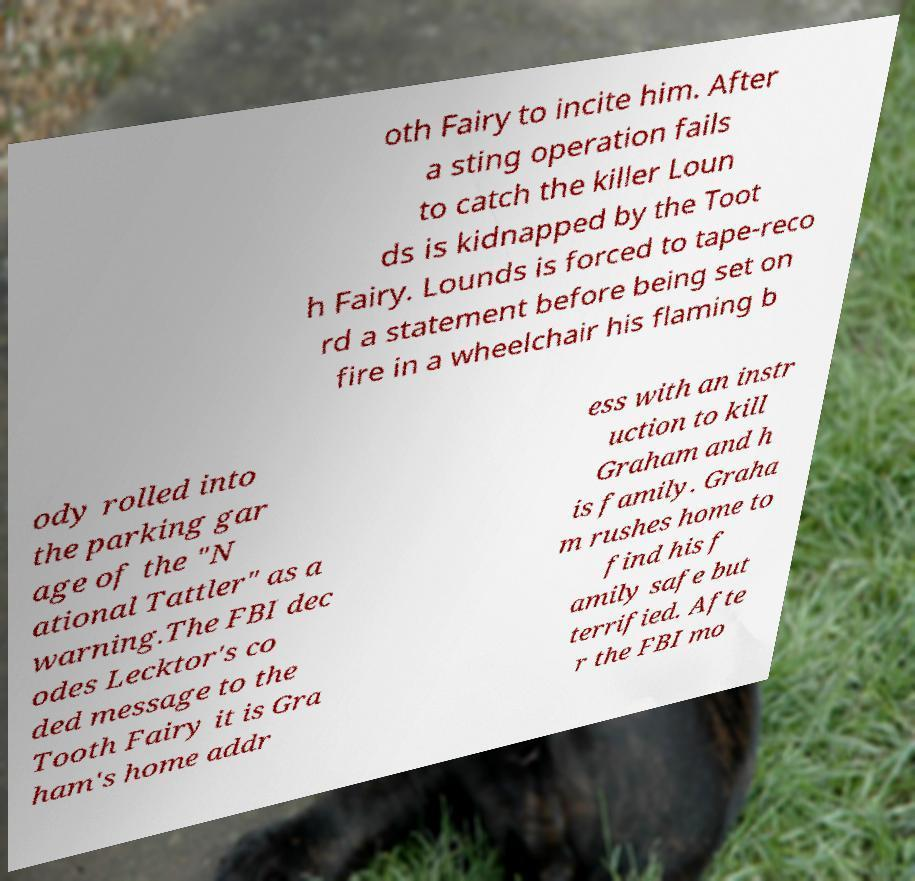Please identify and transcribe the text found in this image. oth Fairy to incite him. After a sting operation fails to catch the killer Loun ds is kidnapped by the Toot h Fairy. Lounds is forced to tape-reco rd a statement before being set on fire in a wheelchair his flaming b ody rolled into the parking gar age of the "N ational Tattler" as a warning.The FBI dec odes Lecktor's co ded message to the Tooth Fairy it is Gra ham's home addr ess with an instr uction to kill Graham and h is family. Graha m rushes home to find his f amily safe but terrified. Afte r the FBI mo 